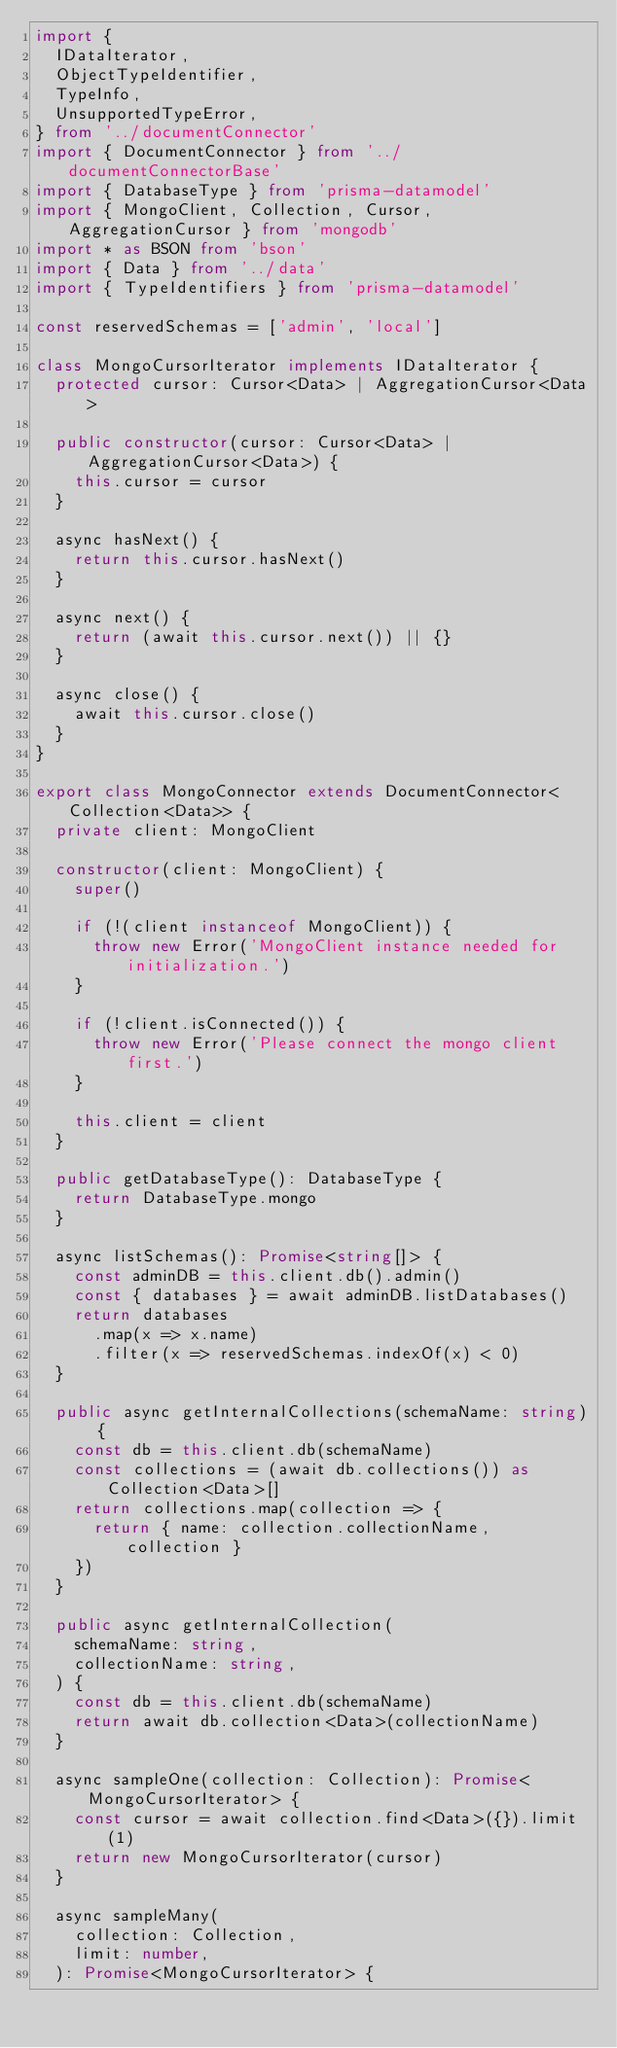<code> <loc_0><loc_0><loc_500><loc_500><_TypeScript_>import {
  IDataIterator,
  ObjectTypeIdentifier,
  TypeInfo,
  UnsupportedTypeError,
} from '../documentConnector'
import { DocumentConnector } from '../documentConnectorBase'
import { DatabaseType } from 'prisma-datamodel'
import { MongoClient, Collection, Cursor, AggregationCursor } from 'mongodb'
import * as BSON from 'bson'
import { Data } from '../data'
import { TypeIdentifiers } from 'prisma-datamodel'

const reservedSchemas = ['admin', 'local']

class MongoCursorIterator implements IDataIterator {
  protected cursor: Cursor<Data> | AggregationCursor<Data>

  public constructor(cursor: Cursor<Data> | AggregationCursor<Data>) {
    this.cursor = cursor
  }

  async hasNext() {
    return this.cursor.hasNext()
  }

  async next() {
    return (await this.cursor.next()) || {}
  }

  async close() {
    await this.cursor.close()
  }
}

export class MongoConnector extends DocumentConnector<Collection<Data>> {
  private client: MongoClient

  constructor(client: MongoClient) {
    super()

    if (!(client instanceof MongoClient)) {
      throw new Error('MongoClient instance needed for initialization.')
    }

    if (!client.isConnected()) {
      throw new Error('Please connect the mongo client first.')
    }

    this.client = client
  }

  public getDatabaseType(): DatabaseType {
    return DatabaseType.mongo
  }

  async listSchemas(): Promise<string[]> {
    const adminDB = this.client.db().admin()
    const { databases } = await adminDB.listDatabases()
    return databases
      .map(x => x.name)
      .filter(x => reservedSchemas.indexOf(x) < 0)
  }

  public async getInternalCollections(schemaName: string) {
    const db = this.client.db(schemaName)
    const collections = (await db.collections()) as Collection<Data>[]
    return collections.map(collection => {
      return { name: collection.collectionName, collection }
    })
  }

  public async getInternalCollection(
    schemaName: string,
    collectionName: string,
  ) {
    const db = this.client.db(schemaName)
    return await db.collection<Data>(collectionName)
  }

  async sampleOne(collection: Collection): Promise<MongoCursorIterator> {
    const cursor = await collection.find<Data>({}).limit(1)
    return new MongoCursorIterator(cursor)
  }

  async sampleMany(
    collection: Collection,
    limit: number,
  ): Promise<MongoCursorIterator> {</code> 